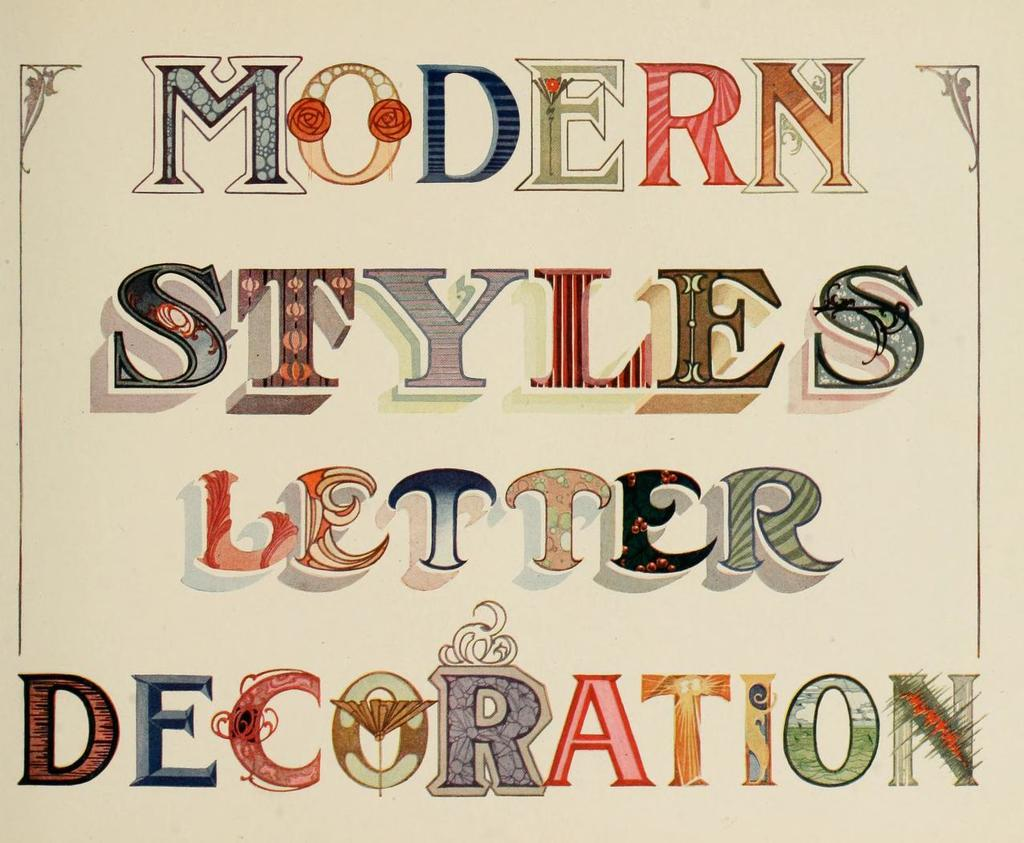What is the main subject of the image? The main subject of the image is a paper. Can you describe the paper in the image? The paper is in the center of the image. Is there any text or markings on the paper? Yes, there is writing on the paper. What type of gun is depicted on the paper in the image? There is no gun depicted on the paper in the image; it only contains writing. What kind of apparel is being worn by the person holding the paper in the image? There is no person holding the paper in the image; it is simply a paper with writing on it. 